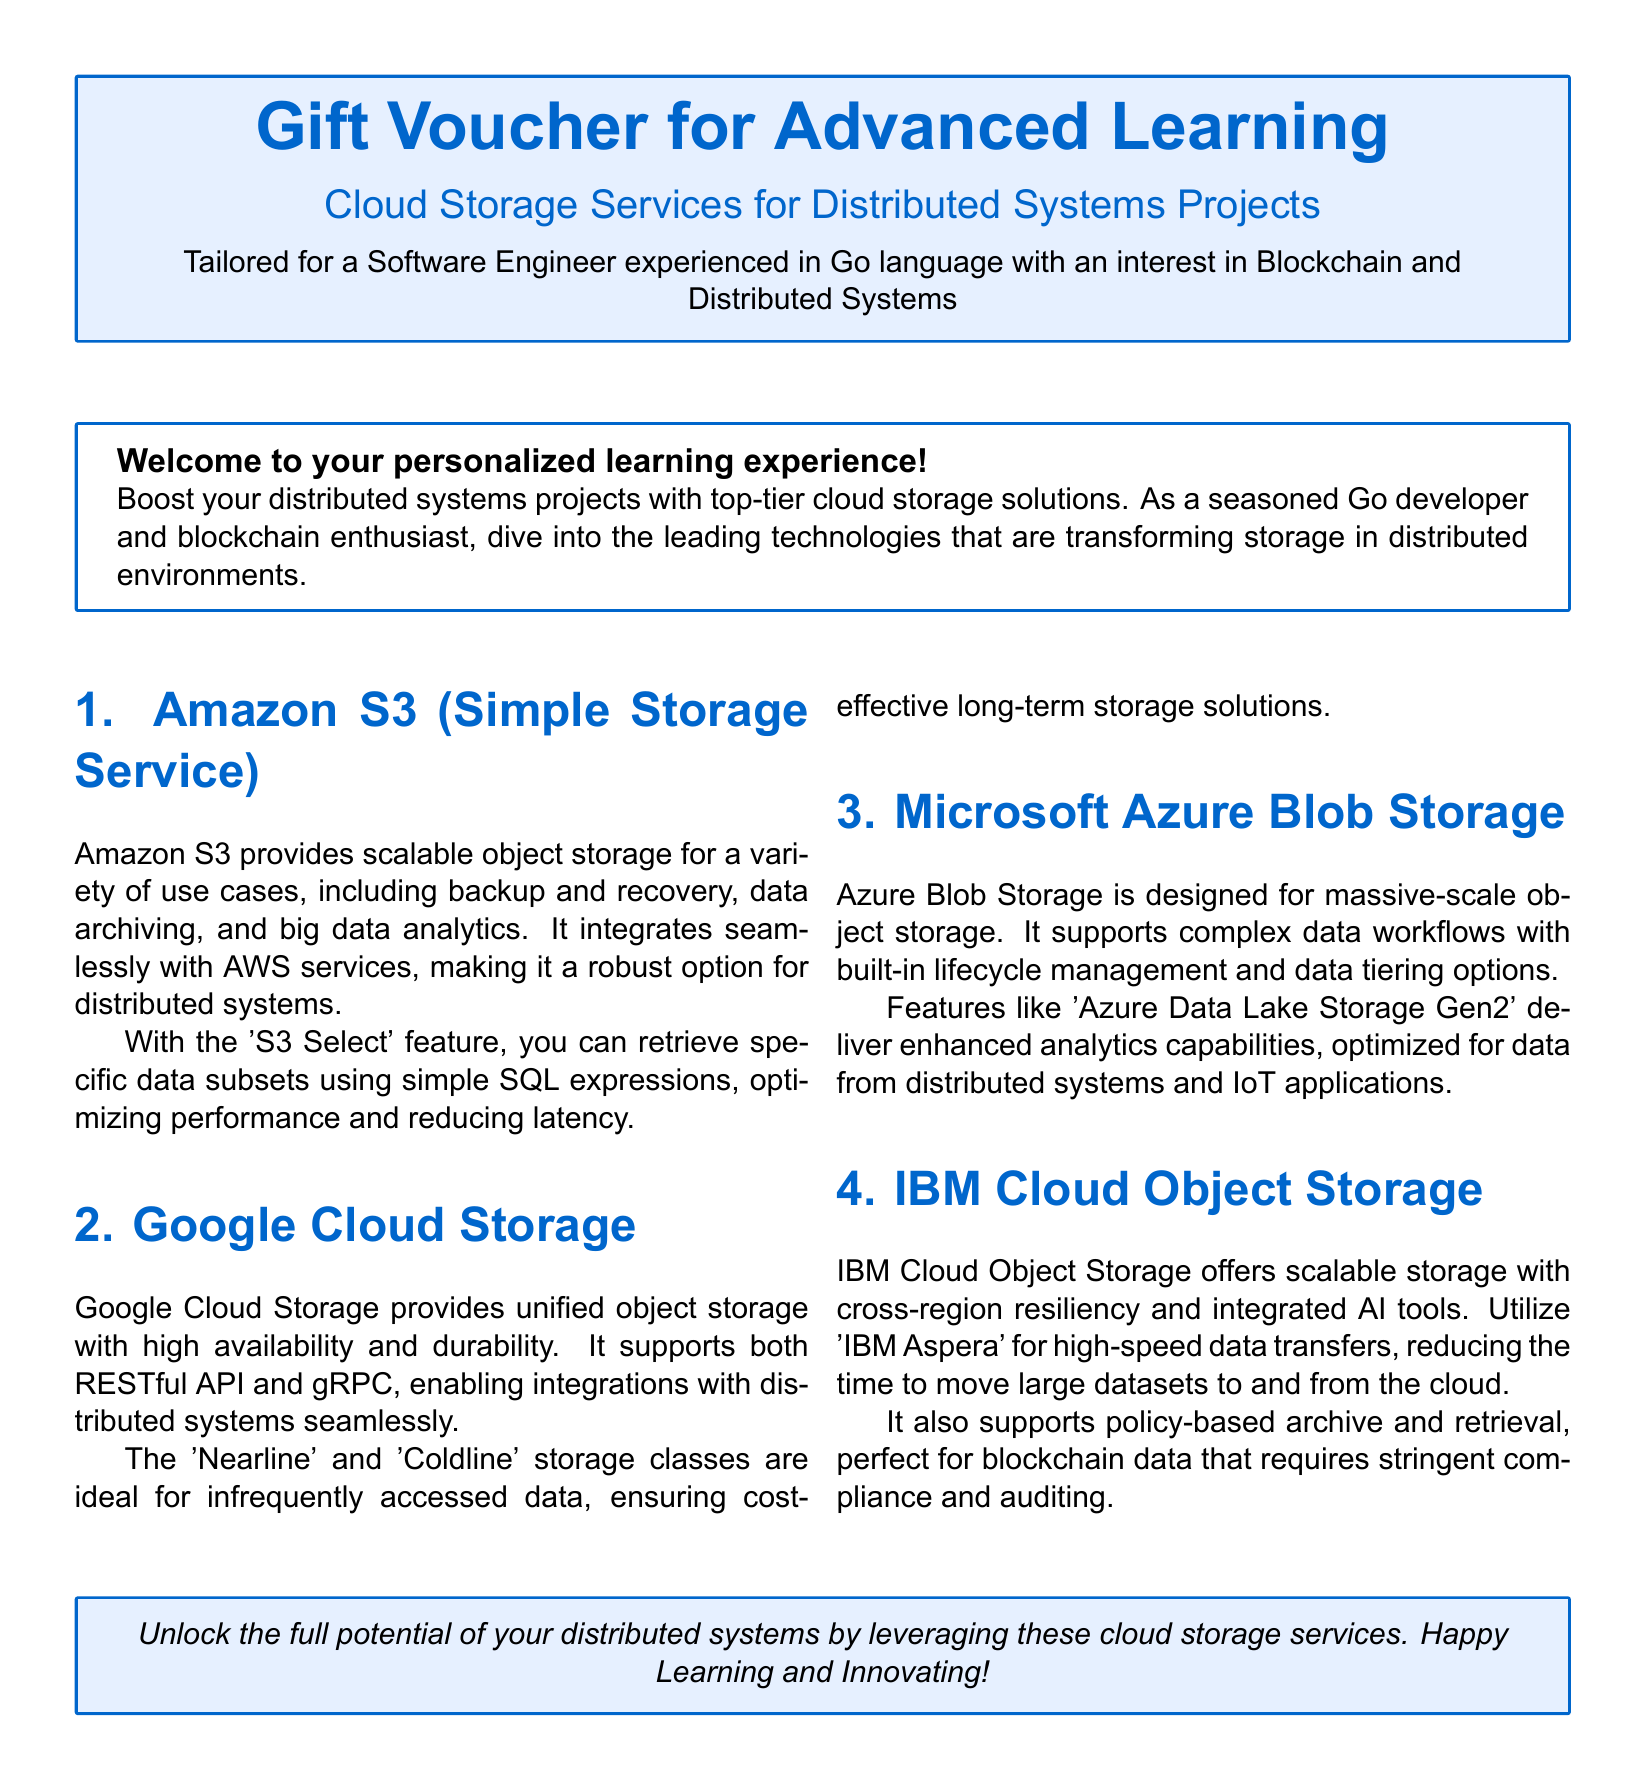What is the title of the gift voucher? The title of the gift voucher is prominently stated at the top of the document.
Answer: Gift Voucher for Advanced Learning What services does this voucher focus on? The document specifically mentions the types of services that are highlighted within its content.
Answer: Cloud Storage Services Which programming language is mentioned in the description? The description points out a specific programming language relevant to the audience of the voucher.
Answer: Go language How many cloud storage services are listed in the document? The document lists a certain number of cloud storage services tailored for distributed systems projects.
Answer: Four What feature does Amazon S3 offer for performance optimization? A specific feature of Amazon S3 is designed to enhance data retrieval performance based on the document.
Answer: S3 Select Which storage class from Google Cloud Storage is intended for infrequent access? The document illustrates specific storage classes designed for different use cases within Google Cloud Storage.
Answer: Nearline What does IBM Cloud Object Storage integrate for high-speed data transfers? The document mentions a specific tool that facilitates data transfers within IBM Cloud Object Storage’s offerings.
Answer: IBM Aspera What is the purpose of the voucher message at the end? The concluding message offers encouragement about utilizing the services mentioned in the document.
Answer: Unlock the full potential 